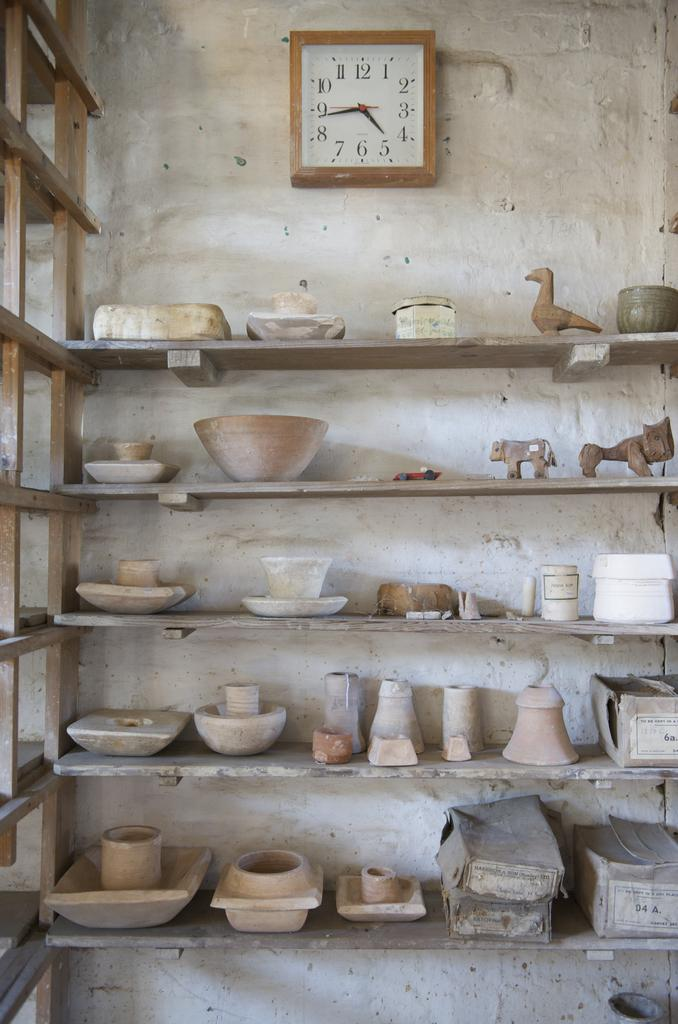<image>
Share a concise interpretation of the image provided. A square clock hanging above shelves of pottery shows the time is 4:44. 